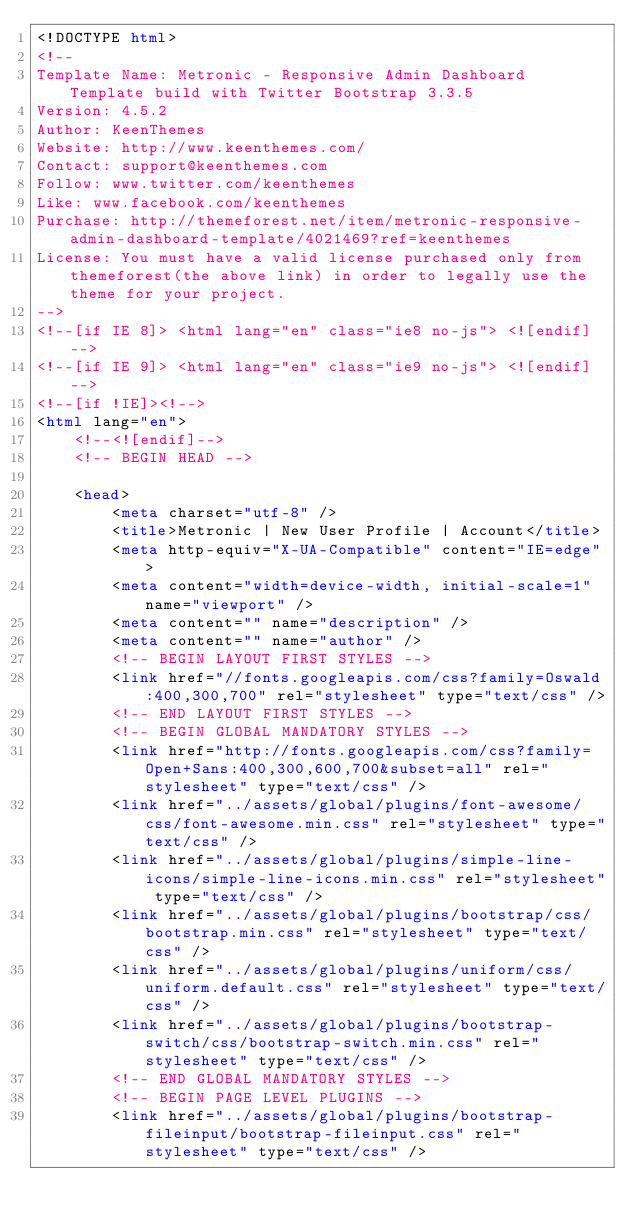Convert code to text. <code><loc_0><loc_0><loc_500><loc_500><_HTML_><!DOCTYPE html>
<!-- 
Template Name: Metronic - Responsive Admin Dashboard Template build with Twitter Bootstrap 3.3.5
Version: 4.5.2
Author: KeenThemes
Website: http://www.keenthemes.com/
Contact: support@keenthemes.com
Follow: www.twitter.com/keenthemes
Like: www.facebook.com/keenthemes
Purchase: http://themeforest.net/item/metronic-responsive-admin-dashboard-template/4021469?ref=keenthemes
License: You must have a valid license purchased only from themeforest(the above link) in order to legally use the theme for your project.
-->
<!--[if IE 8]> <html lang="en" class="ie8 no-js"> <![endif]-->
<!--[if IE 9]> <html lang="en" class="ie9 no-js"> <![endif]-->
<!--[if !IE]><!-->
<html lang="en">
    <!--<![endif]-->
    <!-- BEGIN HEAD -->

    <head>
        <meta charset="utf-8" />
        <title>Metronic | New User Profile | Account</title>
        <meta http-equiv="X-UA-Compatible" content="IE=edge">
        <meta content="width=device-width, initial-scale=1" name="viewport" />
        <meta content="" name="description" />
        <meta content="" name="author" />
        <!-- BEGIN LAYOUT FIRST STYLES -->
        <link href="//fonts.googleapis.com/css?family=Oswald:400,300,700" rel="stylesheet" type="text/css" />
        <!-- END LAYOUT FIRST STYLES -->
        <!-- BEGIN GLOBAL MANDATORY STYLES -->
        <link href="http://fonts.googleapis.com/css?family=Open+Sans:400,300,600,700&subset=all" rel="stylesheet" type="text/css" />
        <link href="../assets/global/plugins/font-awesome/css/font-awesome.min.css" rel="stylesheet" type="text/css" />
        <link href="../assets/global/plugins/simple-line-icons/simple-line-icons.min.css" rel="stylesheet" type="text/css" />
        <link href="../assets/global/plugins/bootstrap/css/bootstrap.min.css" rel="stylesheet" type="text/css" />
        <link href="../assets/global/plugins/uniform/css/uniform.default.css" rel="stylesheet" type="text/css" />
        <link href="../assets/global/plugins/bootstrap-switch/css/bootstrap-switch.min.css" rel="stylesheet" type="text/css" />
        <!-- END GLOBAL MANDATORY STYLES -->
        <!-- BEGIN PAGE LEVEL PLUGINS -->
        <link href="../assets/global/plugins/bootstrap-fileinput/bootstrap-fileinput.css" rel="stylesheet" type="text/css" /></code> 